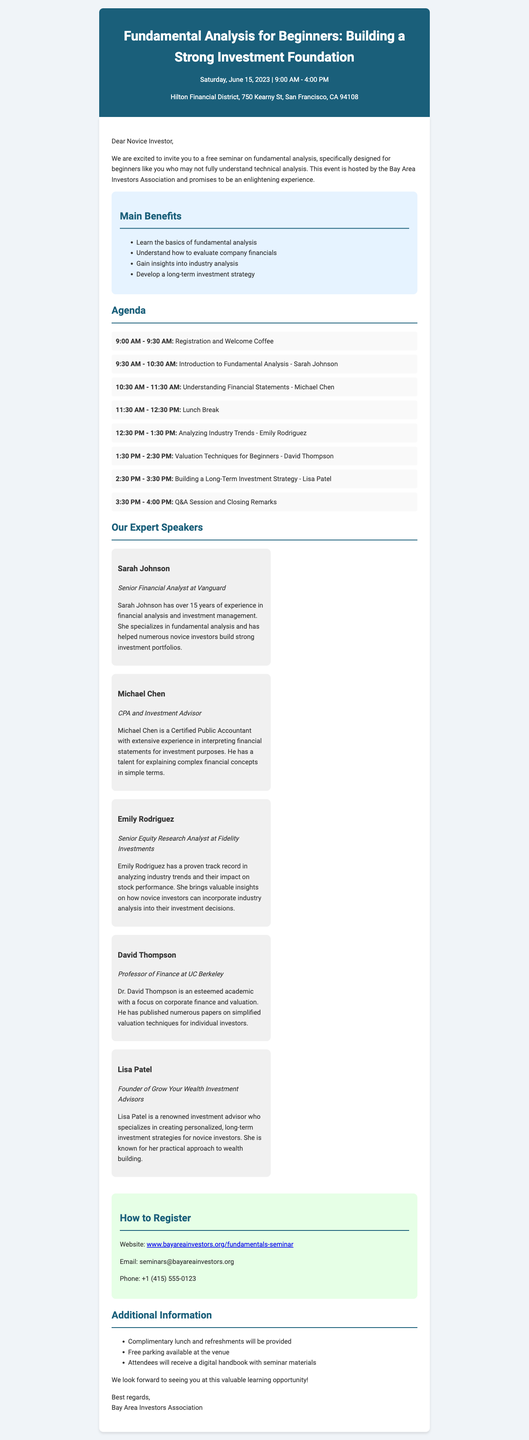What is the seminar title? The seminar title is clearly mentioned at the top of the document.
Answer: Fundamental Analysis for Beginners: Building a Strong Investment Foundation When is the seminar scheduled? The date of the seminar is explicitly stated in the document.
Answer: Saturday, June 15, 2023 What venue will the seminar be held at? The venue is provided in the document for attendees.
Answer: Hilton Financial District, 750 Kearny St, San Francisco, CA 94108 Who is the organizing body of the seminar? The document specifies the host organization directly.
Answer: Bay Area Investors Association What is the duration of the lunch break? The agenda indicates the length of the lunch break.
Answer: 1 hour Name one benefit of attending the seminar. The benefits section lists multiple advantages clearly.
Answer: Learn the basics of fundamental analysis Who is the speaker for the session on Understanding Financial Statements? The agenda lists the speakers alongside their topics.
Answer: Michael Chen How can attendees register for the seminar? The registration section provides details on how to sign up effectively.
Answer: Website: www.bayareainvestors.org/fundamentals-seminar What type of audience is the seminar targeting? The document clearly states the target audience for the seminar.
Answer: Novice investors with limited knowledge of technical analysis 